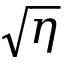Convert formula to latex. <formula><loc_0><loc_0><loc_500><loc_500>\sqrt { \eta }</formula> 